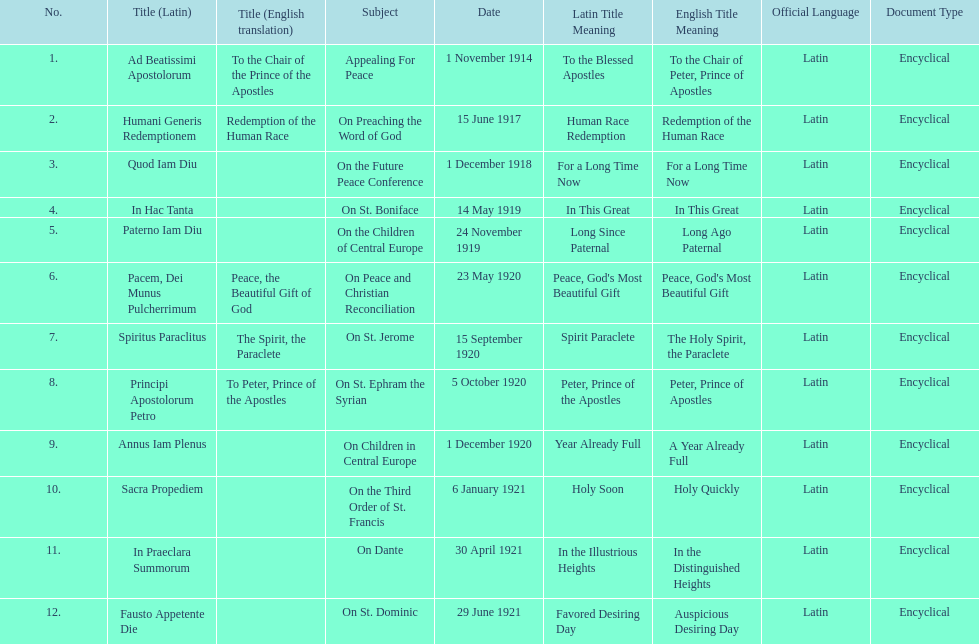After 1 december 1918 when was the next encyclical? 14 May 1919. 